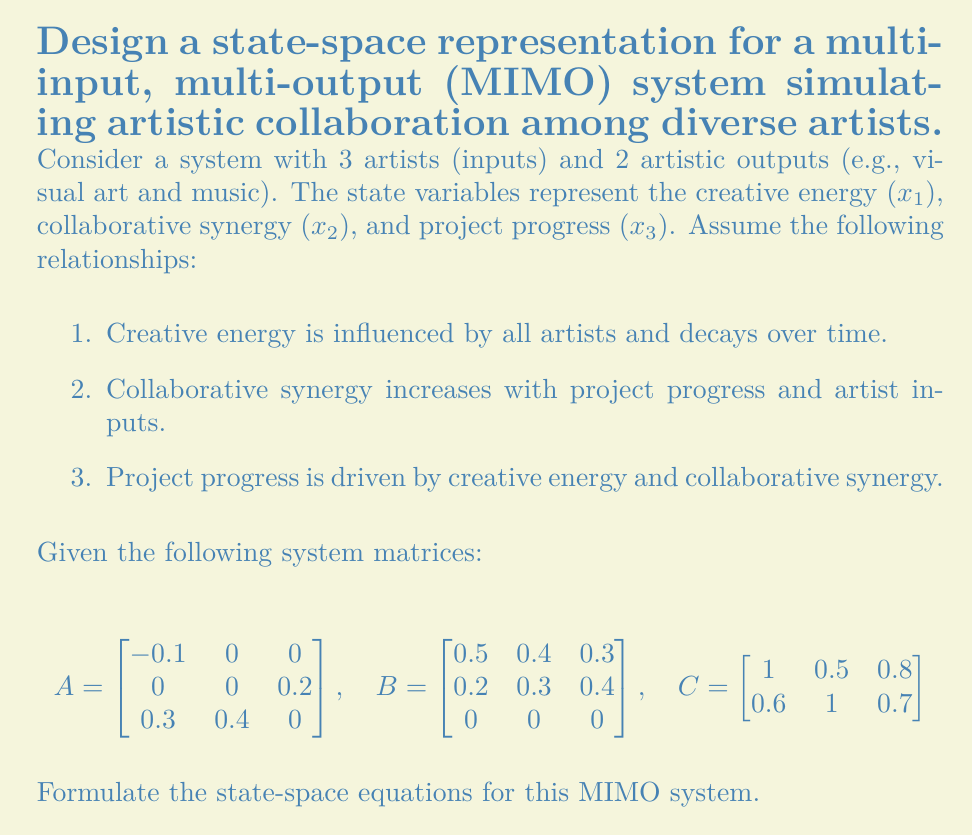Can you solve this math problem? To formulate the state-space equations for this MIMO system, we need to use the standard state-space representation:

$$\dot{x} = Ax + Bu$$
$$y = Cx + Du$$

Where:
- $x$ is the state vector
- $u$ is the input vector
- $y$ is the output vector
- $A$ is the system matrix
- $B$ is the input matrix
- $C$ is the output matrix
- $D$ is the feedthrough matrix (usually 0 for most physical systems)

Given:
- 3 state variables: $x_1$ (creative energy), $x_2$ (collaborative synergy), $x_3$ (project progress)
- 3 inputs (artists): $u_1$, $u_2$, $u_3$
- 2 outputs (artistic outputs): $y_1$ (visual art), $y_2$ (music)

Step 1: Write the state equation
$$\begin{bmatrix} 
\dot{x_1} \\
\dot{x_2} \\
\dot{x_3}
\end{bmatrix} = 
\begin{bmatrix} 
-0.1 & 0 & 0 \\
0 & 0 & 0.2 \\
0.3 & 0.4 & 0
\end{bmatrix}
\begin{bmatrix} 
x_1 \\
x_2 \\
x_3
\end{bmatrix} +
\begin{bmatrix}
0.5 & 0.4 & 0.3 \\
0.2 & 0.3 & 0.4 \\
0 & 0 & 0
\end{bmatrix}
\begin{bmatrix} 
u_1 \\
u_2 \\
u_3
\end{bmatrix}$$

Step 2: Write the output equation
$$\begin{bmatrix} 
y_1 \\
y_2
\end{bmatrix} =
\begin{bmatrix}
1 & 0.5 & 0.8 \\
0.6 & 1 & 0.7
\end{bmatrix}
\begin{bmatrix} 
x_1 \\
x_2 \\
x_3
\end{bmatrix}$$

Note that we assume $D = 0$ in this case, as there's no direct feedthrough from inputs to outputs.

Step 3: Expand the equations
State equations:
$$\dot{x_1} = -0.1x_1 + 0.5u_1 + 0.4u_2 + 0.3u_3$$
$$\dot{x_2} = 0.2x_3 + 0.2u_1 + 0.3u_2 + 0.4u_3$$
$$\dot{x_3} = 0.3x_1 + 0.4x_2$$

Output equations:
$$y_1 = x_1 + 0.5x_2 + 0.8x_3$$
$$y_2 = 0.6x_1 + x_2 + 0.7x_3$$

These equations fully describe the state-space representation of the given MIMO system simulating artistic collaboration.
Answer: $$\begin{aligned}
\dot{x} &= Ax + Bu \\
y &= Cx
\end{aligned}$$

Where:
$$\begin{aligned}
A &= \begin{bmatrix} 
-0.1 & 0 & 0 \\
0 & 0 & 0.2 \\
0.3 & 0.4 & 0
\end{bmatrix},
B &= \begin{bmatrix}
0.5 & 0.4 & 0.3 \\
0.2 & 0.3 & 0.4 \\
0 & 0 & 0
\end{bmatrix},
C &= \begin{bmatrix}
1 & 0.5 & 0.8 \\
0.6 & 1 & 0.7
\end{bmatrix}
\end{aligned}$$ 